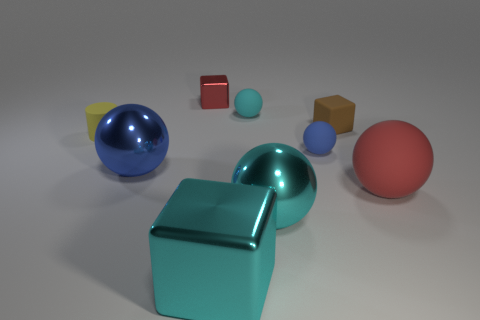What color is the cube that is the same size as the red rubber thing? The cube that is the same size as the red rubber object is cyan. This cyan cube appears to have the same dimensions and shape as the red object, which is located closer to the foreground of the image. 